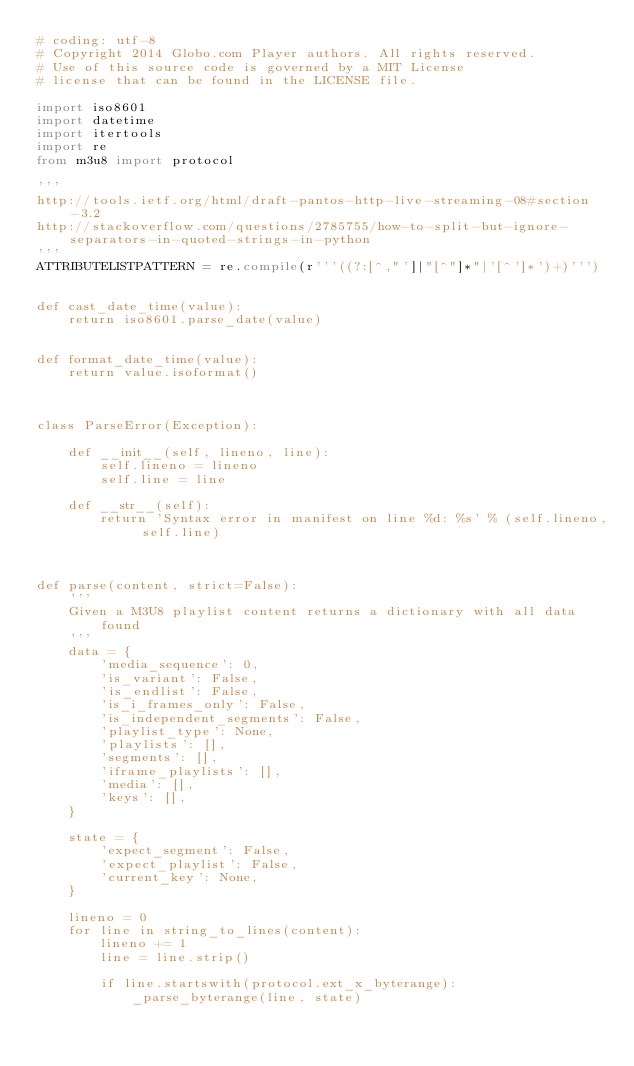Convert code to text. <code><loc_0><loc_0><loc_500><loc_500><_Python_># coding: utf-8
# Copyright 2014 Globo.com Player authors. All rights reserved.
# Use of this source code is governed by a MIT License
# license that can be found in the LICENSE file.

import iso8601
import datetime
import itertools
import re
from m3u8 import protocol

'''
http://tools.ietf.org/html/draft-pantos-http-live-streaming-08#section-3.2
http://stackoverflow.com/questions/2785755/how-to-split-but-ignore-separators-in-quoted-strings-in-python
'''
ATTRIBUTELISTPATTERN = re.compile(r'''((?:[^,"']|"[^"]*"|'[^']*')+)''')


def cast_date_time(value):
    return iso8601.parse_date(value)


def format_date_time(value):
    return value.isoformat()



class ParseError(Exception):

    def __init__(self, lineno, line):
        self.lineno = lineno
        self.line = line

    def __str__(self):
        return 'Syntax error in manifest on line %d: %s' % (self.lineno, self.line)



def parse(content, strict=False):
    '''
    Given a M3U8 playlist content returns a dictionary with all data found
    '''
    data = {
        'media_sequence': 0,
        'is_variant': False,
        'is_endlist': False,
        'is_i_frames_only': False,
        'is_independent_segments': False,
        'playlist_type': None,
        'playlists': [],
        'segments': [],
        'iframe_playlists': [],
        'media': [],
        'keys': [],
    }

    state = {
        'expect_segment': False,
        'expect_playlist': False,
        'current_key': None,
    }

    lineno = 0
    for line in string_to_lines(content):
        lineno += 1
        line = line.strip()

        if line.startswith(protocol.ext_x_byterange):
            _parse_byterange(line, state)</code> 